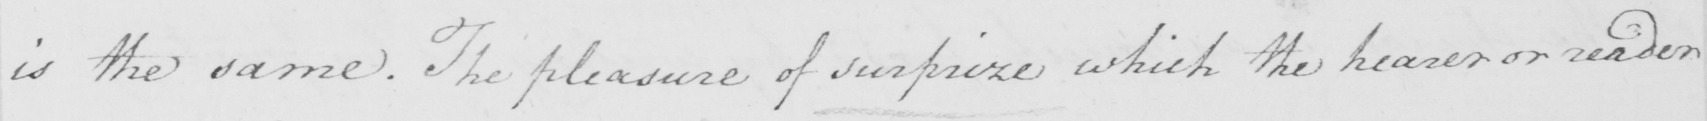Please transcribe the handwritten text in this image. is the same . The pleasure of surprize which the hearer or reader 